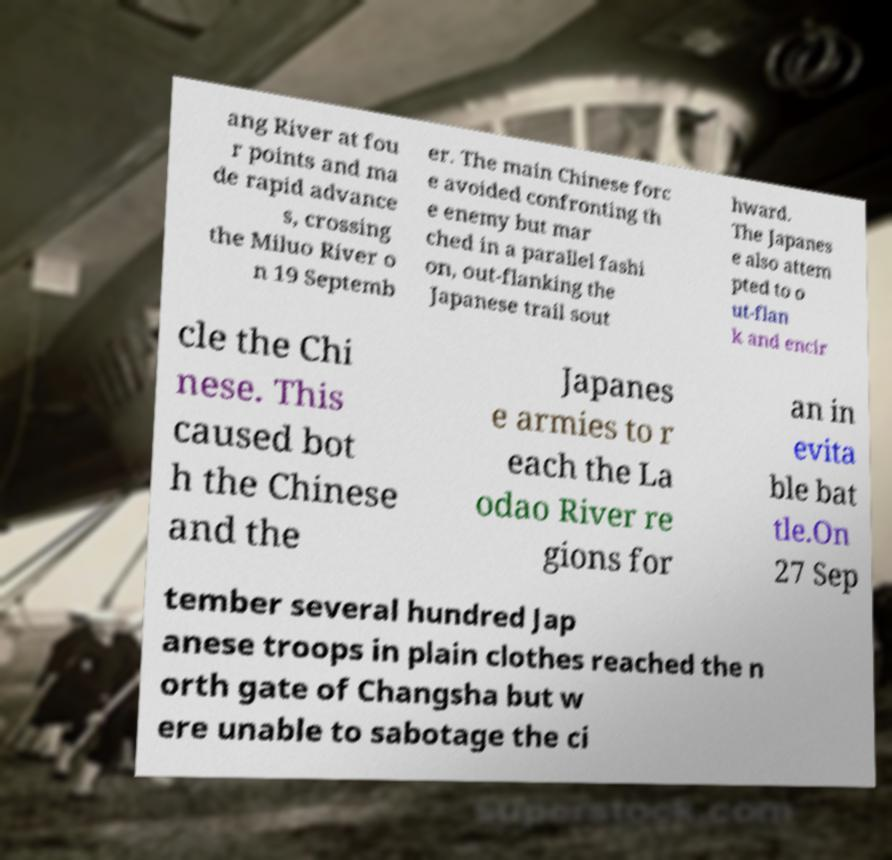Can you read and provide the text displayed in the image?This photo seems to have some interesting text. Can you extract and type it out for me? ang River at fou r points and ma de rapid advance s, crossing the Miluo River o n 19 Septemb er. The main Chinese forc e avoided confronting th e enemy but mar ched in a parallel fashi on, out-flanking the Japanese trail sout hward. The Japanes e also attem pted to o ut-flan k and encir cle the Chi nese. This caused bot h the Chinese and the Japanes e armies to r each the La odao River re gions for an in evita ble bat tle.On 27 Sep tember several hundred Jap anese troops in plain clothes reached the n orth gate of Changsha but w ere unable to sabotage the ci 